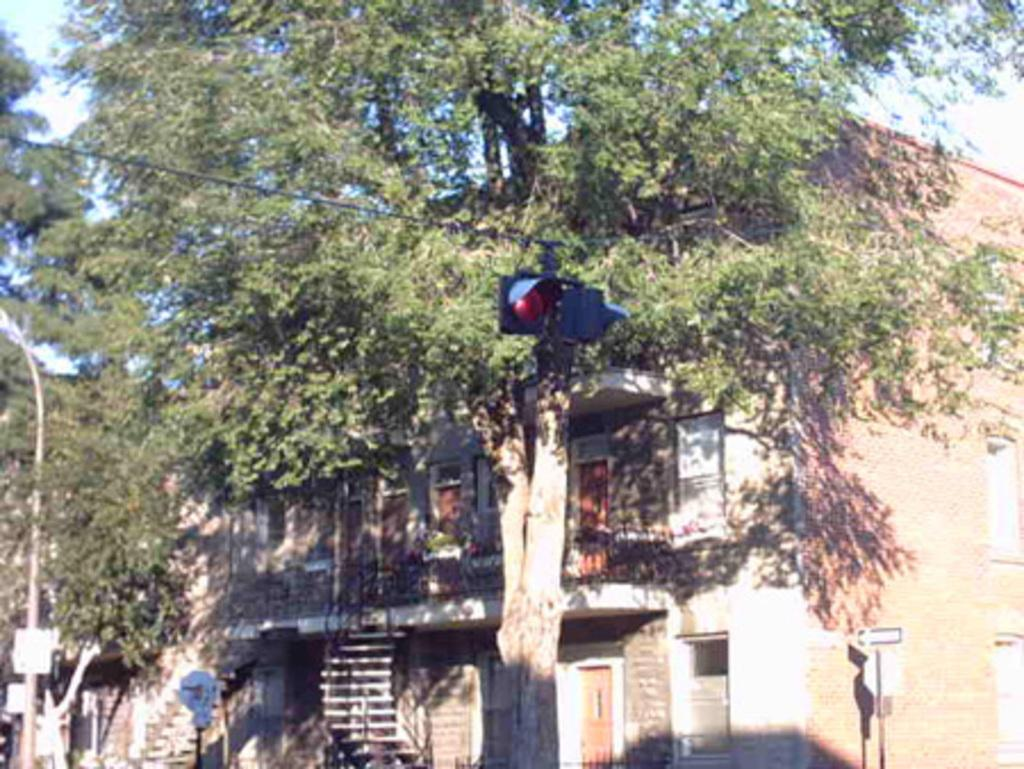What is the main object in the image? There is a traffic signal in the image. How is the traffic signal supported? The traffic signal is attached to a cable. What type of natural elements can be seen in the image? There are trees visible in the image. What type of man-made structure is present in the image? There is a building in the image. What other objects can be seen in the image related to traffic or directions? There are poles with signboards in the image. What part of the environment is visible in the image? The sky is visible in the image. What type of roof can be seen on the traffic signal in the image? There is no roof on the traffic signal in the image; it is an open structure. What substance is being used to create a net in the image? There is no net present in the image. 